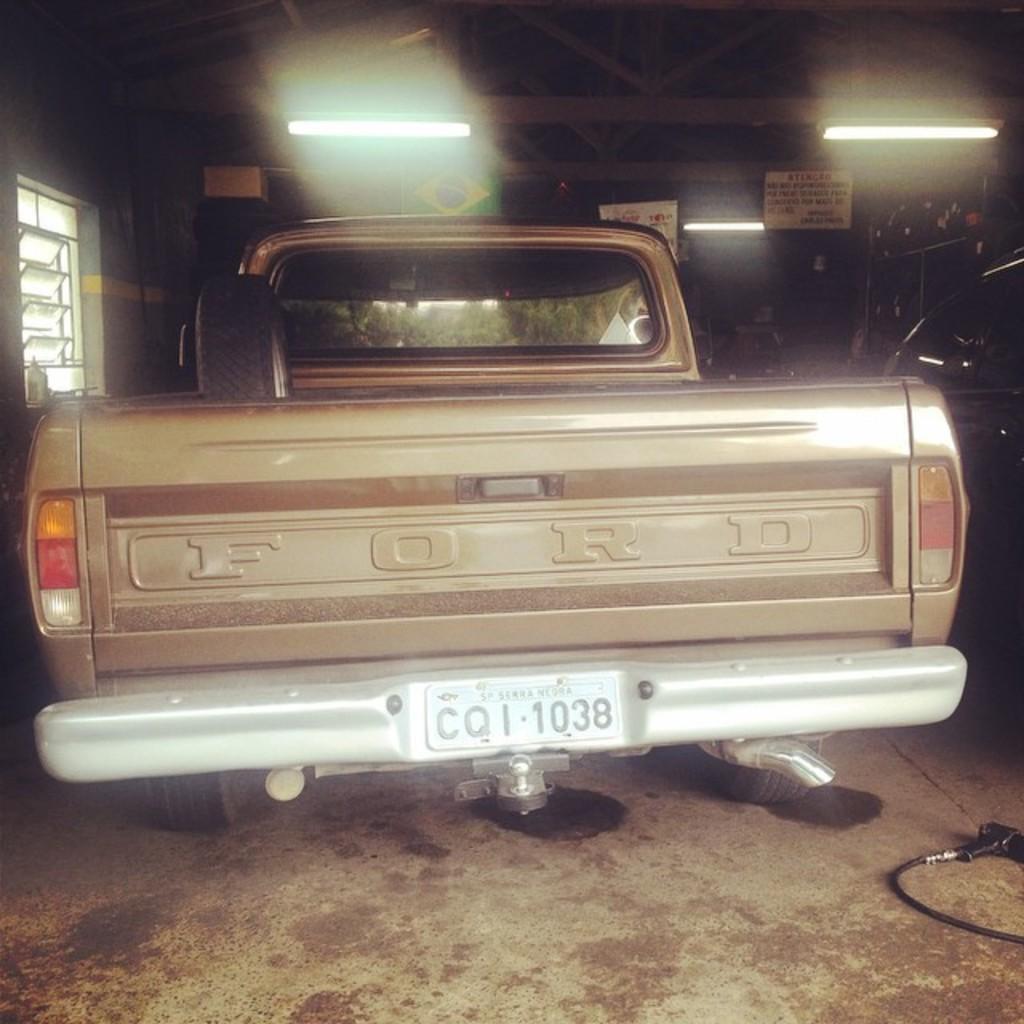Describe this image in one or two sentences. In this picture, we see a vehicle and a number plate in white color. In the right bottom, we see a wire and an object in black color. On the right side, we see a black car. In the background, we see a wall. At the top, we see the lights and the roof of the building. On the left side, we see a wall and the windows. This picture might be clicked in the garage. 